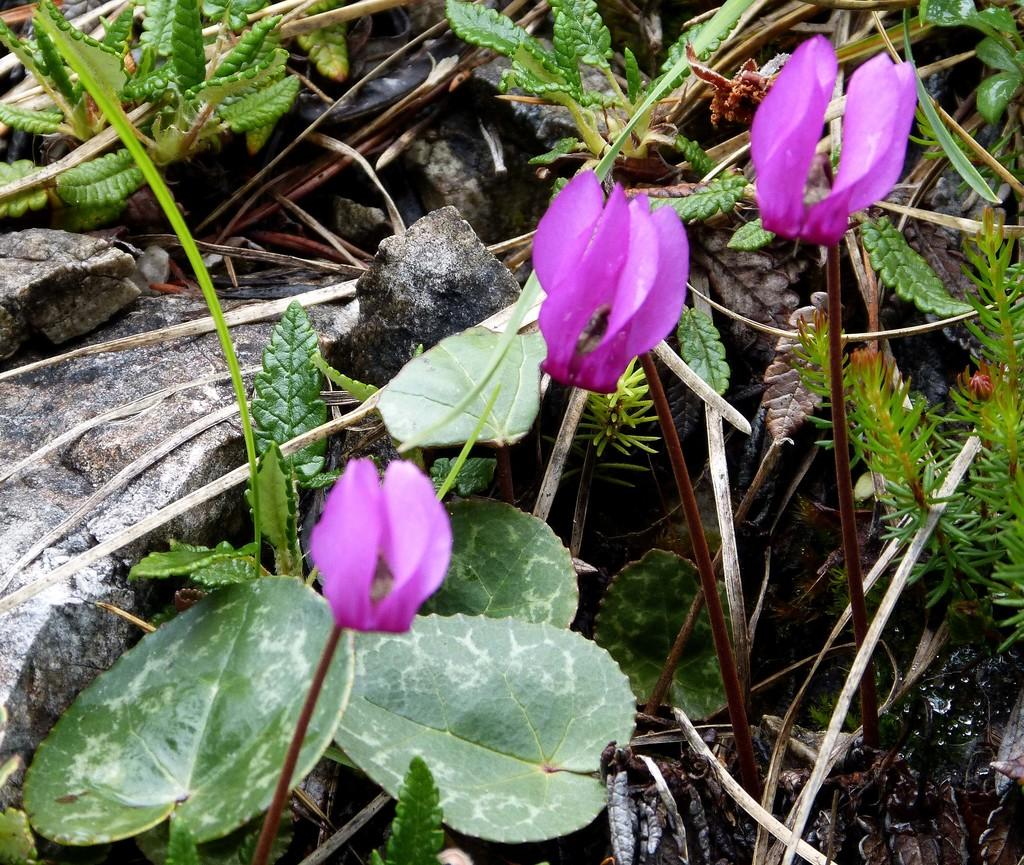What is the main subject in the center of the image? There are plants in the center of the image. What can be seen growing on the plants? There are flowers visible in the image. What other objects are present in the image? There are rocks in the image. How many bikes can be seen in the image? There are no bikes present in the image. What type of bone is visible in the image? There is no bone present in the image. 